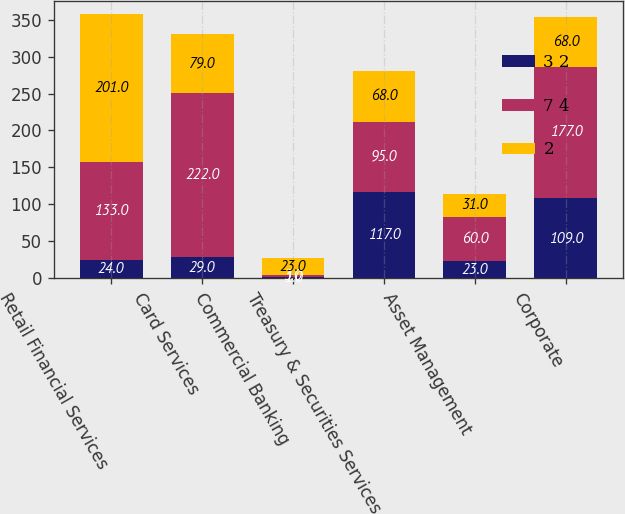Convert chart. <chart><loc_0><loc_0><loc_500><loc_500><stacked_bar_chart><ecel><fcel>Retail Financial Services<fcel>Card Services<fcel>Commercial Banking<fcel>Treasury & Securities Services<fcel>Asset Management<fcel>Corporate<nl><fcel>3 2<fcel>24<fcel>29<fcel>1<fcel>117<fcel>23<fcel>109<nl><fcel>7 4<fcel>133<fcel>222<fcel>3<fcel>95<fcel>60<fcel>177<nl><fcel>2<fcel>201<fcel>79<fcel>23<fcel>68<fcel>31<fcel>68<nl></chart> 